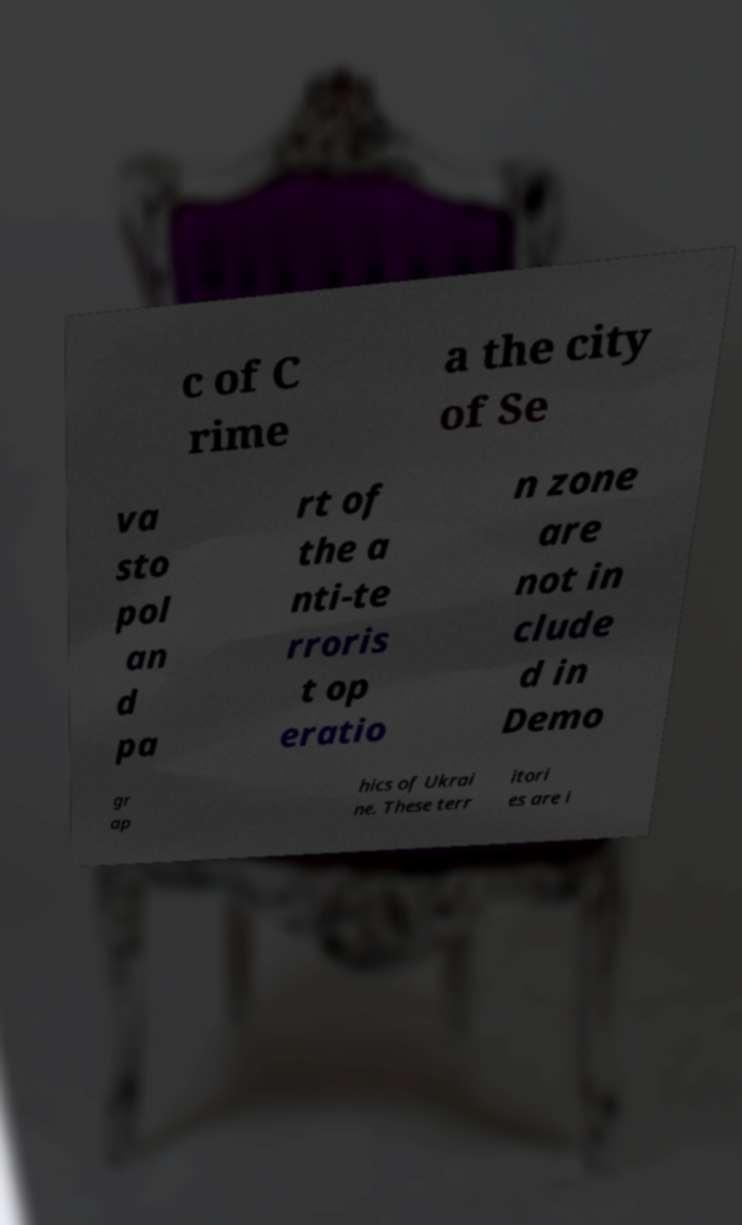Could you assist in decoding the text presented in this image and type it out clearly? c of C rime a the city of Se va sto pol an d pa rt of the a nti-te rroris t op eratio n zone are not in clude d in Demo gr ap hics of Ukrai ne. These terr itori es are i 